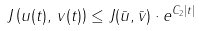Convert formula to latex. <formula><loc_0><loc_0><loc_500><loc_500>J \left ( u ( t ) , \, v ( t ) \right ) \leq J ( \bar { u } , \bar { v } ) \cdot e ^ { C _ { 2 } | t | }</formula> 